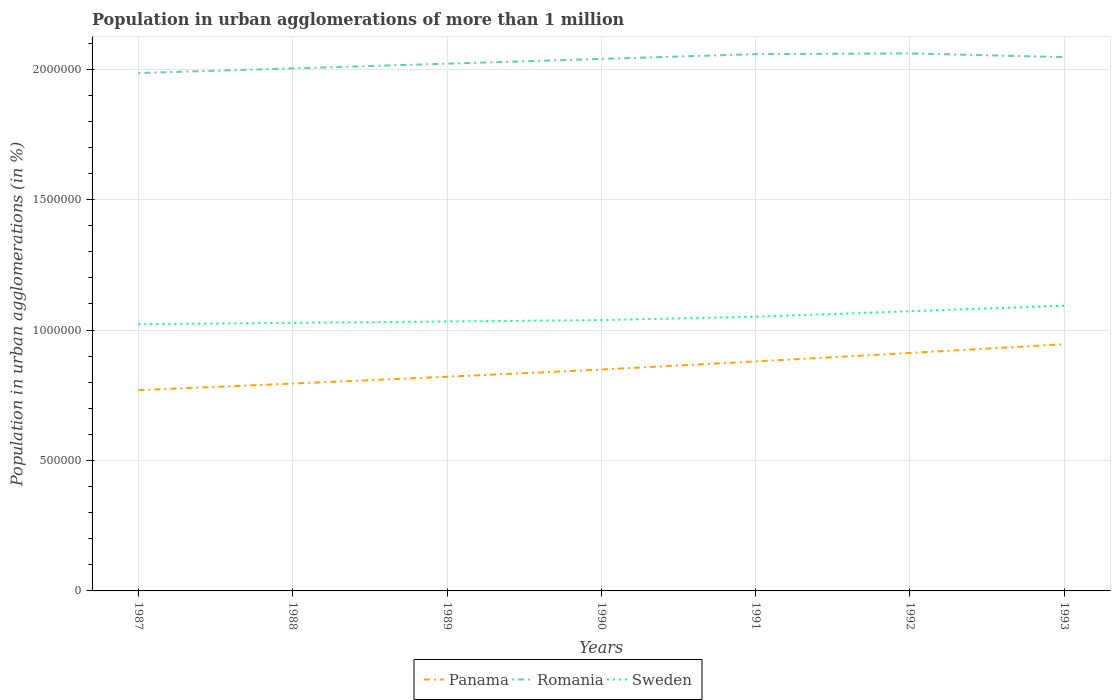Across all years, what is the maximum population in urban agglomerations in Sweden?
Provide a succinct answer. 1.02e+06. In which year was the population in urban agglomerations in Panama maximum?
Your answer should be compact. 1987. What is the total population in urban agglomerations in Romania in the graph?
Your response must be concise. -3.93e+04. What is the difference between the highest and the second highest population in urban agglomerations in Panama?
Provide a succinct answer. 1.76e+05. How many years are there in the graph?
Your answer should be compact. 7. What is the difference between two consecutive major ticks on the Y-axis?
Provide a succinct answer. 5.00e+05. Are the values on the major ticks of Y-axis written in scientific E-notation?
Provide a short and direct response. No. Does the graph contain grids?
Provide a succinct answer. Yes. How many legend labels are there?
Ensure brevity in your answer.  3. What is the title of the graph?
Keep it short and to the point. Population in urban agglomerations of more than 1 million. Does "Arab World" appear as one of the legend labels in the graph?
Your response must be concise. No. What is the label or title of the X-axis?
Offer a terse response. Years. What is the label or title of the Y-axis?
Your response must be concise. Population in urban agglomerations (in %). What is the Population in urban agglomerations (in %) of Panama in 1987?
Your response must be concise. 7.70e+05. What is the Population in urban agglomerations (in %) in Romania in 1987?
Make the answer very short. 1.99e+06. What is the Population in urban agglomerations (in %) of Sweden in 1987?
Offer a very short reply. 1.02e+06. What is the Population in urban agglomerations (in %) in Panama in 1988?
Your response must be concise. 7.95e+05. What is the Population in urban agglomerations (in %) of Romania in 1988?
Make the answer very short. 2.00e+06. What is the Population in urban agglomerations (in %) of Sweden in 1988?
Keep it short and to the point. 1.03e+06. What is the Population in urban agglomerations (in %) in Panama in 1989?
Ensure brevity in your answer.  8.21e+05. What is the Population in urban agglomerations (in %) in Romania in 1989?
Offer a very short reply. 2.02e+06. What is the Population in urban agglomerations (in %) of Sweden in 1989?
Your response must be concise. 1.03e+06. What is the Population in urban agglomerations (in %) in Panama in 1990?
Provide a short and direct response. 8.49e+05. What is the Population in urban agglomerations (in %) of Romania in 1990?
Provide a succinct answer. 2.04e+06. What is the Population in urban agglomerations (in %) in Sweden in 1990?
Make the answer very short. 1.04e+06. What is the Population in urban agglomerations (in %) in Panama in 1991?
Give a very brief answer. 8.80e+05. What is the Population in urban agglomerations (in %) of Romania in 1991?
Offer a very short reply. 2.06e+06. What is the Population in urban agglomerations (in %) of Sweden in 1991?
Your response must be concise. 1.05e+06. What is the Population in urban agglomerations (in %) in Panama in 1992?
Provide a succinct answer. 9.12e+05. What is the Population in urban agglomerations (in %) of Romania in 1992?
Your answer should be very brief. 2.06e+06. What is the Population in urban agglomerations (in %) of Sweden in 1992?
Give a very brief answer. 1.07e+06. What is the Population in urban agglomerations (in %) in Panama in 1993?
Give a very brief answer. 9.46e+05. What is the Population in urban agglomerations (in %) of Romania in 1993?
Give a very brief answer. 2.05e+06. What is the Population in urban agglomerations (in %) of Sweden in 1993?
Keep it short and to the point. 1.09e+06. Across all years, what is the maximum Population in urban agglomerations (in %) in Panama?
Your response must be concise. 9.46e+05. Across all years, what is the maximum Population in urban agglomerations (in %) in Romania?
Your response must be concise. 2.06e+06. Across all years, what is the maximum Population in urban agglomerations (in %) of Sweden?
Keep it short and to the point. 1.09e+06. Across all years, what is the minimum Population in urban agglomerations (in %) in Panama?
Offer a terse response. 7.70e+05. Across all years, what is the minimum Population in urban agglomerations (in %) of Romania?
Keep it short and to the point. 1.99e+06. Across all years, what is the minimum Population in urban agglomerations (in %) in Sweden?
Provide a succinct answer. 1.02e+06. What is the total Population in urban agglomerations (in %) in Panama in the graph?
Your answer should be very brief. 5.97e+06. What is the total Population in urban agglomerations (in %) in Romania in the graph?
Make the answer very short. 1.42e+07. What is the total Population in urban agglomerations (in %) in Sweden in the graph?
Give a very brief answer. 7.34e+06. What is the difference between the Population in urban agglomerations (in %) of Panama in 1987 and that in 1988?
Your answer should be very brief. -2.54e+04. What is the difference between the Population in urban agglomerations (in %) of Romania in 1987 and that in 1988?
Give a very brief answer. -1.79e+04. What is the difference between the Population in urban agglomerations (in %) of Sweden in 1987 and that in 1988?
Make the answer very short. -5207. What is the difference between the Population in urban agglomerations (in %) of Panama in 1987 and that in 1989?
Your answer should be very brief. -5.16e+04. What is the difference between the Population in urban agglomerations (in %) of Romania in 1987 and that in 1989?
Keep it short and to the point. -3.59e+04. What is the difference between the Population in urban agglomerations (in %) of Sweden in 1987 and that in 1989?
Offer a very short reply. -1.04e+04. What is the difference between the Population in urban agglomerations (in %) of Panama in 1987 and that in 1990?
Make the answer very short. -7.91e+04. What is the difference between the Population in urban agglomerations (in %) of Romania in 1987 and that in 1990?
Your answer should be compact. -5.41e+04. What is the difference between the Population in urban agglomerations (in %) in Sweden in 1987 and that in 1990?
Give a very brief answer. -1.57e+04. What is the difference between the Population in urban agglomerations (in %) of Panama in 1987 and that in 1991?
Keep it short and to the point. -1.10e+05. What is the difference between the Population in urban agglomerations (in %) of Romania in 1987 and that in 1991?
Your answer should be very brief. -7.25e+04. What is the difference between the Population in urban agglomerations (in %) in Sweden in 1987 and that in 1991?
Keep it short and to the point. -2.86e+04. What is the difference between the Population in urban agglomerations (in %) of Panama in 1987 and that in 1992?
Your answer should be compact. -1.43e+05. What is the difference between the Population in urban agglomerations (in %) in Romania in 1987 and that in 1992?
Make the answer very short. -7.53e+04. What is the difference between the Population in urban agglomerations (in %) in Sweden in 1987 and that in 1992?
Ensure brevity in your answer.  -4.96e+04. What is the difference between the Population in urban agglomerations (in %) of Panama in 1987 and that in 1993?
Offer a very short reply. -1.76e+05. What is the difference between the Population in urban agglomerations (in %) of Romania in 1987 and that in 1993?
Your answer should be very brief. -6.10e+04. What is the difference between the Population in urban agglomerations (in %) of Sweden in 1987 and that in 1993?
Provide a short and direct response. -7.10e+04. What is the difference between the Population in urban agglomerations (in %) of Panama in 1988 and that in 1989?
Your answer should be very brief. -2.62e+04. What is the difference between the Population in urban agglomerations (in %) in Romania in 1988 and that in 1989?
Give a very brief answer. -1.80e+04. What is the difference between the Population in urban agglomerations (in %) in Sweden in 1988 and that in 1989?
Give a very brief answer. -5220. What is the difference between the Population in urban agglomerations (in %) of Panama in 1988 and that in 1990?
Ensure brevity in your answer.  -5.37e+04. What is the difference between the Population in urban agglomerations (in %) in Romania in 1988 and that in 1990?
Provide a short and direct response. -3.62e+04. What is the difference between the Population in urban agglomerations (in %) of Sweden in 1988 and that in 1990?
Provide a succinct answer. -1.05e+04. What is the difference between the Population in urban agglomerations (in %) of Panama in 1988 and that in 1991?
Provide a succinct answer. -8.49e+04. What is the difference between the Population in urban agglomerations (in %) of Romania in 1988 and that in 1991?
Make the answer very short. -5.46e+04. What is the difference between the Population in urban agglomerations (in %) in Sweden in 1988 and that in 1991?
Make the answer very short. -2.34e+04. What is the difference between the Population in urban agglomerations (in %) in Panama in 1988 and that in 1992?
Your response must be concise. -1.17e+05. What is the difference between the Population in urban agglomerations (in %) in Romania in 1988 and that in 1992?
Offer a terse response. -5.74e+04. What is the difference between the Population in urban agglomerations (in %) in Sweden in 1988 and that in 1992?
Your response must be concise. -4.44e+04. What is the difference between the Population in urban agglomerations (in %) of Panama in 1988 and that in 1993?
Provide a short and direct response. -1.51e+05. What is the difference between the Population in urban agglomerations (in %) in Romania in 1988 and that in 1993?
Offer a terse response. -4.31e+04. What is the difference between the Population in urban agglomerations (in %) of Sweden in 1988 and that in 1993?
Make the answer very short. -6.58e+04. What is the difference between the Population in urban agglomerations (in %) of Panama in 1989 and that in 1990?
Make the answer very short. -2.75e+04. What is the difference between the Population in urban agglomerations (in %) of Romania in 1989 and that in 1990?
Ensure brevity in your answer.  -1.82e+04. What is the difference between the Population in urban agglomerations (in %) in Sweden in 1989 and that in 1990?
Ensure brevity in your answer.  -5253. What is the difference between the Population in urban agglomerations (in %) of Panama in 1989 and that in 1991?
Your answer should be very brief. -5.87e+04. What is the difference between the Population in urban agglomerations (in %) in Romania in 1989 and that in 1991?
Provide a succinct answer. -3.66e+04. What is the difference between the Population in urban agglomerations (in %) of Sweden in 1989 and that in 1991?
Your answer should be very brief. -1.82e+04. What is the difference between the Population in urban agglomerations (in %) of Panama in 1989 and that in 1992?
Ensure brevity in your answer.  -9.11e+04. What is the difference between the Population in urban agglomerations (in %) of Romania in 1989 and that in 1992?
Your response must be concise. -3.93e+04. What is the difference between the Population in urban agglomerations (in %) of Sweden in 1989 and that in 1992?
Your answer should be compact. -3.92e+04. What is the difference between the Population in urban agglomerations (in %) in Panama in 1989 and that in 1993?
Offer a terse response. -1.25e+05. What is the difference between the Population in urban agglomerations (in %) of Romania in 1989 and that in 1993?
Give a very brief answer. -2.51e+04. What is the difference between the Population in urban agglomerations (in %) of Sweden in 1989 and that in 1993?
Keep it short and to the point. -6.06e+04. What is the difference between the Population in urban agglomerations (in %) in Panama in 1990 and that in 1991?
Ensure brevity in your answer.  -3.12e+04. What is the difference between the Population in urban agglomerations (in %) in Romania in 1990 and that in 1991?
Your answer should be compact. -1.84e+04. What is the difference between the Population in urban agglomerations (in %) in Sweden in 1990 and that in 1991?
Ensure brevity in your answer.  -1.29e+04. What is the difference between the Population in urban agglomerations (in %) in Panama in 1990 and that in 1992?
Provide a succinct answer. -6.36e+04. What is the difference between the Population in urban agglomerations (in %) in Romania in 1990 and that in 1992?
Offer a terse response. -2.11e+04. What is the difference between the Population in urban agglomerations (in %) in Sweden in 1990 and that in 1992?
Your response must be concise. -3.39e+04. What is the difference between the Population in urban agglomerations (in %) in Panama in 1990 and that in 1993?
Provide a succinct answer. -9.71e+04. What is the difference between the Population in urban agglomerations (in %) in Romania in 1990 and that in 1993?
Your response must be concise. -6881. What is the difference between the Population in urban agglomerations (in %) of Sweden in 1990 and that in 1993?
Give a very brief answer. -5.53e+04. What is the difference between the Population in urban agglomerations (in %) in Panama in 1991 and that in 1992?
Offer a terse response. -3.24e+04. What is the difference between the Population in urban agglomerations (in %) of Romania in 1991 and that in 1992?
Provide a succinct answer. -2740. What is the difference between the Population in urban agglomerations (in %) of Sweden in 1991 and that in 1992?
Keep it short and to the point. -2.10e+04. What is the difference between the Population in urban agglomerations (in %) in Panama in 1991 and that in 1993?
Your response must be concise. -6.59e+04. What is the difference between the Population in urban agglomerations (in %) of Romania in 1991 and that in 1993?
Provide a short and direct response. 1.15e+04. What is the difference between the Population in urban agglomerations (in %) of Sweden in 1991 and that in 1993?
Make the answer very short. -4.24e+04. What is the difference between the Population in urban agglomerations (in %) in Panama in 1992 and that in 1993?
Your response must be concise. -3.35e+04. What is the difference between the Population in urban agglomerations (in %) in Romania in 1992 and that in 1993?
Your answer should be very brief. 1.42e+04. What is the difference between the Population in urban agglomerations (in %) in Sweden in 1992 and that in 1993?
Ensure brevity in your answer.  -2.14e+04. What is the difference between the Population in urban agglomerations (in %) of Panama in 1987 and the Population in urban agglomerations (in %) of Romania in 1988?
Provide a succinct answer. -1.23e+06. What is the difference between the Population in urban agglomerations (in %) in Panama in 1987 and the Population in urban agglomerations (in %) in Sweden in 1988?
Offer a terse response. -2.58e+05. What is the difference between the Population in urban agglomerations (in %) in Romania in 1987 and the Population in urban agglomerations (in %) in Sweden in 1988?
Your answer should be very brief. 9.58e+05. What is the difference between the Population in urban agglomerations (in %) in Panama in 1987 and the Population in urban agglomerations (in %) in Romania in 1989?
Your answer should be compact. -1.25e+06. What is the difference between the Population in urban agglomerations (in %) of Panama in 1987 and the Population in urban agglomerations (in %) of Sweden in 1989?
Provide a short and direct response. -2.63e+05. What is the difference between the Population in urban agglomerations (in %) of Romania in 1987 and the Population in urban agglomerations (in %) of Sweden in 1989?
Your answer should be very brief. 9.52e+05. What is the difference between the Population in urban agglomerations (in %) in Panama in 1987 and the Population in urban agglomerations (in %) in Romania in 1990?
Keep it short and to the point. -1.27e+06. What is the difference between the Population in urban agglomerations (in %) in Panama in 1987 and the Population in urban agglomerations (in %) in Sweden in 1990?
Give a very brief answer. -2.69e+05. What is the difference between the Population in urban agglomerations (in %) in Romania in 1987 and the Population in urban agglomerations (in %) in Sweden in 1990?
Offer a terse response. 9.47e+05. What is the difference between the Population in urban agglomerations (in %) in Panama in 1987 and the Population in urban agglomerations (in %) in Romania in 1991?
Offer a very short reply. -1.29e+06. What is the difference between the Population in urban agglomerations (in %) of Panama in 1987 and the Population in urban agglomerations (in %) of Sweden in 1991?
Keep it short and to the point. -2.82e+05. What is the difference between the Population in urban agglomerations (in %) of Romania in 1987 and the Population in urban agglomerations (in %) of Sweden in 1991?
Provide a succinct answer. 9.34e+05. What is the difference between the Population in urban agglomerations (in %) of Panama in 1987 and the Population in urban agglomerations (in %) of Romania in 1992?
Offer a very short reply. -1.29e+06. What is the difference between the Population in urban agglomerations (in %) in Panama in 1987 and the Population in urban agglomerations (in %) in Sweden in 1992?
Provide a succinct answer. -3.03e+05. What is the difference between the Population in urban agglomerations (in %) in Romania in 1987 and the Population in urban agglomerations (in %) in Sweden in 1992?
Provide a succinct answer. 9.13e+05. What is the difference between the Population in urban agglomerations (in %) in Panama in 1987 and the Population in urban agglomerations (in %) in Romania in 1993?
Keep it short and to the point. -1.28e+06. What is the difference between the Population in urban agglomerations (in %) in Panama in 1987 and the Population in urban agglomerations (in %) in Sweden in 1993?
Make the answer very short. -3.24e+05. What is the difference between the Population in urban agglomerations (in %) of Romania in 1987 and the Population in urban agglomerations (in %) of Sweden in 1993?
Your response must be concise. 8.92e+05. What is the difference between the Population in urban agglomerations (in %) of Panama in 1988 and the Population in urban agglomerations (in %) of Romania in 1989?
Provide a short and direct response. -1.23e+06. What is the difference between the Population in urban agglomerations (in %) in Panama in 1988 and the Population in urban agglomerations (in %) in Sweden in 1989?
Offer a very short reply. -2.38e+05. What is the difference between the Population in urban agglomerations (in %) in Romania in 1988 and the Population in urban agglomerations (in %) in Sweden in 1989?
Your response must be concise. 9.70e+05. What is the difference between the Population in urban agglomerations (in %) in Panama in 1988 and the Population in urban agglomerations (in %) in Romania in 1990?
Your answer should be compact. -1.24e+06. What is the difference between the Population in urban agglomerations (in %) of Panama in 1988 and the Population in urban agglomerations (in %) of Sweden in 1990?
Offer a terse response. -2.43e+05. What is the difference between the Population in urban agglomerations (in %) in Romania in 1988 and the Population in urban agglomerations (in %) in Sweden in 1990?
Your answer should be very brief. 9.65e+05. What is the difference between the Population in urban agglomerations (in %) of Panama in 1988 and the Population in urban agglomerations (in %) of Romania in 1991?
Ensure brevity in your answer.  -1.26e+06. What is the difference between the Population in urban agglomerations (in %) in Panama in 1988 and the Population in urban agglomerations (in %) in Sweden in 1991?
Your response must be concise. -2.56e+05. What is the difference between the Population in urban agglomerations (in %) of Romania in 1988 and the Population in urban agglomerations (in %) of Sweden in 1991?
Offer a very short reply. 9.52e+05. What is the difference between the Population in urban agglomerations (in %) of Panama in 1988 and the Population in urban agglomerations (in %) of Romania in 1992?
Keep it short and to the point. -1.27e+06. What is the difference between the Population in urban agglomerations (in %) in Panama in 1988 and the Population in urban agglomerations (in %) in Sweden in 1992?
Your answer should be compact. -2.77e+05. What is the difference between the Population in urban agglomerations (in %) in Romania in 1988 and the Population in urban agglomerations (in %) in Sweden in 1992?
Provide a short and direct response. 9.31e+05. What is the difference between the Population in urban agglomerations (in %) in Panama in 1988 and the Population in urban agglomerations (in %) in Romania in 1993?
Offer a very short reply. -1.25e+06. What is the difference between the Population in urban agglomerations (in %) in Panama in 1988 and the Population in urban agglomerations (in %) in Sweden in 1993?
Provide a succinct answer. -2.99e+05. What is the difference between the Population in urban agglomerations (in %) in Romania in 1988 and the Population in urban agglomerations (in %) in Sweden in 1993?
Make the answer very short. 9.10e+05. What is the difference between the Population in urban agglomerations (in %) of Panama in 1989 and the Population in urban agglomerations (in %) of Romania in 1990?
Make the answer very short. -1.22e+06. What is the difference between the Population in urban agglomerations (in %) of Panama in 1989 and the Population in urban agglomerations (in %) of Sweden in 1990?
Your answer should be very brief. -2.17e+05. What is the difference between the Population in urban agglomerations (in %) in Romania in 1989 and the Population in urban agglomerations (in %) in Sweden in 1990?
Offer a terse response. 9.83e+05. What is the difference between the Population in urban agglomerations (in %) of Panama in 1989 and the Population in urban agglomerations (in %) of Romania in 1991?
Your answer should be compact. -1.24e+06. What is the difference between the Population in urban agglomerations (in %) of Panama in 1989 and the Population in urban agglomerations (in %) of Sweden in 1991?
Provide a short and direct response. -2.30e+05. What is the difference between the Population in urban agglomerations (in %) of Romania in 1989 and the Population in urban agglomerations (in %) of Sweden in 1991?
Ensure brevity in your answer.  9.70e+05. What is the difference between the Population in urban agglomerations (in %) of Panama in 1989 and the Population in urban agglomerations (in %) of Romania in 1992?
Provide a short and direct response. -1.24e+06. What is the difference between the Population in urban agglomerations (in %) of Panama in 1989 and the Population in urban agglomerations (in %) of Sweden in 1992?
Provide a succinct answer. -2.51e+05. What is the difference between the Population in urban agglomerations (in %) of Romania in 1989 and the Population in urban agglomerations (in %) of Sweden in 1992?
Your response must be concise. 9.49e+05. What is the difference between the Population in urban agglomerations (in %) of Panama in 1989 and the Population in urban agglomerations (in %) of Romania in 1993?
Your response must be concise. -1.23e+06. What is the difference between the Population in urban agglomerations (in %) in Panama in 1989 and the Population in urban agglomerations (in %) in Sweden in 1993?
Keep it short and to the point. -2.72e+05. What is the difference between the Population in urban agglomerations (in %) of Romania in 1989 and the Population in urban agglomerations (in %) of Sweden in 1993?
Make the answer very short. 9.28e+05. What is the difference between the Population in urban agglomerations (in %) in Panama in 1990 and the Population in urban agglomerations (in %) in Romania in 1991?
Provide a succinct answer. -1.21e+06. What is the difference between the Population in urban agglomerations (in %) of Panama in 1990 and the Population in urban agglomerations (in %) of Sweden in 1991?
Your answer should be compact. -2.03e+05. What is the difference between the Population in urban agglomerations (in %) in Romania in 1990 and the Population in urban agglomerations (in %) in Sweden in 1991?
Your answer should be compact. 9.88e+05. What is the difference between the Population in urban agglomerations (in %) of Panama in 1990 and the Population in urban agglomerations (in %) of Romania in 1992?
Provide a short and direct response. -1.21e+06. What is the difference between the Population in urban agglomerations (in %) in Panama in 1990 and the Population in urban agglomerations (in %) in Sweden in 1992?
Offer a terse response. -2.24e+05. What is the difference between the Population in urban agglomerations (in %) of Romania in 1990 and the Population in urban agglomerations (in %) of Sweden in 1992?
Keep it short and to the point. 9.67e+05. What is the difference between the Population in urban agglomerations (in %) of Panama in 1990 and the Population in urban agglomerations (in %) of Romania in 1993?
Keep it short and to the point. -1.20e+06. What is the difference between the Population in urban agglomerations (in %) of Panama in 1990 and the Population in urban agglomerations (in %) of Sweden in 1993?
Provide a succinct answer. -2.45e+05. What is the difference between the Population in urban agglomerations (in %) of Romania in 1990 and the Population in urban agglomerations (in %) of Sweden in 1993?
Offer a terse response. 9.46e+05. What is the difference between the Population in urban agglomerations (in %) in Panama in 1991 and the Population in urban agglomerations (in %) in Romania in 1992?
Your answer should be very brief. -1.18e+06. What is the difference between the Population in urban agglomerations (in %) in Panama in 1991 and the Population in urban agglomerations (in %) in Sweden in 1992?
Provide a short and direct response. -1.92e+05. What is the difference between the Population in urban agglomerations (in %) of Romania in 1991 and the Population in urban agglomerations (in %) of Sweden in 1992?
Keep it short and to the point. 9.86e+05. What is the difference between the Population in urban agglomerations (in %) in Panama in 1991 and the Population in urban agglomerations (in %) in Romania in 1993?
Provide a short and direct response. -1.17e+06. What is the difference between the Population in urban agglomerations (in %) in Panama in 1991 and the Population in urban agglomerations (in %) in Sweden in 1993?
Your response must be concise. -2.14e+05. What is the difference between the Population in urban agglomerations (in %) of Romania in 1991 and the Population in urban agglomerations (in %) of Sweden in 1993?
Keep it short and to the point. 9.64e+05. What is the difference between the Population in urban agglomerations (in %) of Panama in 1992 and the Population in urban agglomerations (in %) of Romania in 1993?
Give a very brief answer. -1.13e+06. What is the difference between the Population in urban agglomerations (in %) in Panama in 1992 and the Population in urban agglomerations (in %) in Sweden in 1993?
Provide a succinct answer. -1.81e+05. What is the difference between the Population in urban agglomerations (in %) of Romania in 1992 and the Population in urban agglomerations (in %) of Sweden in 1993?
Give a very brief answer. 9.67e+05. What is the average Population in urban agglomerations (in %) of Panama per year?
Give a very brief answer. 8.53e+05. What is the average Population in urban agglomerations (in %) of Romania per year?
Offer a very short reply. 2.03e+06. What is the average Population in urban agglomerations (in %) of Sweden per year?
Keep it short and to the point. 1.05e+06. In the year 1987, what is the difference between the Population in urban agglomerations (in %) in Panama and Population in urban agglomerations (in %) in Romania?
Ensure brevity in your answer.  -1.22e+06. In the year 1987, what is the difference between the Population in urban agglomerations (in %) of Panama and Population in urban agglomerations (in %) of Sweden?
Your answer should be very brief. -2.53e+05. In the year 1987, what is the difference between the Population in urban agglomerations (in %) in Romania and Population in urban agglomerations (in %) in Sweden?
Your answer should be very brief. 9.63e+05. In the year 1988, what is the difference between the Population in urban agglomerations (in %) of Panama and Population in urban agglomerations (in %) of Romania?
Give a very brief answer. -1.21e+06. In the year 1988, what is the difference between the Population in urban agglomerations (in %) in Panama and Population in urban agglomerations (in %) in Sweden?
Your answer should be very brief. -2.33e+05. In the year 1988, what is the difference between the Population in urban agglomerations (in %) in Romania and Population in urban agglomerations (in %) in Sweden?
Your answer should be compact. 9.76e+05. In the year 1989, what is the difference between the Population in urban agglomerations (in %) in Panama and Population in urban agglomerations (in %) in Romania?
Keep it short and to the point. -1.20e+06. In the year 1989, what is the difference between the Population in urban agglomerations (in %) in Panama and Population in urban agglomerations (in %) in Sweden?
Make the answer very short. -2.12e+05. In the year 1989, what is the difference between the Population in urban agglomerations (in %) of Romania and Population in urban agglomerations (in %) of Sweden?
Your answer should be compact. 9.88e+05. In the year 1990, what is the difference between the Population in urban agglomerations (in %) of Panama and Population in urban agglomerations (in %) of Romania?
Provide a succinct answer. -1.19e+06. In the year 1990, what is the difference between the Population in urban agglomerations (in %) in Panama and Population in urban agglomerations (in %) in Sweden?
Make the answer very short. -1.90e+05. In the year 1990, what is the difference between the Population in urban agglomerations (in %) of Romania and Population in urban agglomerations (in %) of Sweden?
Make the answer very short. 1.00e+06. In the year 1991, what is the difference between the Population in urban agglomerations (in %) of Panama and Population in urban agglomerations (in %) of Romania?
Give a very brief answer. -1.18e+06. In the year 1991, what is the difference between the Population in urban agglomerations (in %) in Panama and Population in urban agglomerations (in %) in Sweden?
Your answer should be very brief. -1.71e+05. In the year 1991, what is the difference between the Population in urban agglomerations (in %) of Romania and Population in urban agglomerations (in %) of Sweden?
Ensure brevity in your answer.  1.01e+06. In the year 1992, what is the difference between the Population in urban agglomerations (in %) in Panama and Population in urban agglomerations (in %) in Romania?
Make the answer very short. -1.15e+06. In the year 1992, what is the difference between the Population in urban agglomerations (in %) in Panama and Population in urban agglomerations (in %) in Sweden?
Offer a very short reply. -1.60e+05. In the year 1992, what is the difference between the Population in urban agglomerations (in %) in Romania and Population in urban agglomerations (in %) in Sweden?
Offer a very short reply. 9.88e+05. In the year 1993, what is the difference between the Population in urban agglomerations (in %) of Panama and Population in urban agglomerations (in %) of Romania?
Your response must be concise. -1.10e+06. In the year 1993, what is the difference between the Population in urban agglomerations (in %) of Panama and Population in urban agglomerations (in %) of Sweden?
Your answer should be very brief. -1.48e+05. In the year 1993, what is the difference between the Population in urban agglomerations (in %) of Romania and Population in urban agglomerations (in %) of Sweden?
Offer a very short reply. 9.53e+05. What is the ratio of the Population in urban agglomerations (in %) of Romania in 1987 to that in 1988?
Offer a very short reply. 0.99. What is the ratio of the Population in urban agglomerations (in %) of Sweden in 1987 to that in 1988?
Make the answer very short. 0.99. What is the ratio of the Population in urban agglomerations (in %) in Panama in 1987 to that in 1989?
Provide a short and direct response. 0.94. What is the ratio of the Population in urban agglomerations (in %) of Romania in 1987 to that in 1989?
Offer a terse response. 0.98. What is the ratio of the Population in urban agglomerations (in %) of Panama in 1987 to that in 1990?
Your response must be concise. 0.91. What is the ratio of the Population in urban agglomerations (in %) in Romania in 1987 to that in 1990?
Provide a succinct answer. 0.97. What is the ratio of the Population in urban agglomerations (in %) in Sweden in 1987 to that in 1990?
Offer a terse response. 0.98. What is the ratio of the Population in urban agglomerations (in %) of Panama in 1987 to that in 1991?
Keep it short and to the point. 0.87. What is the ratio of the Population in urban agglomerations (in %) in Romania in 1987 to that in 1991?
Make the answer very short. 0.96. What is the ratio of the Population in urban agglomerations (in %) in Sweden in 1987 to that in 1991?
Ensure brevity in your answer.  0.97. What is the ratio of the Population in urban agglomerations (in %) in Panama in 1987 to that in 1992?
Keep it short and to the point. 0.84. What is the ratio of the Population in urban agglomerations (in %) of Romania in 1987 to that in 1992?
Provide a short and direct response. 0.96. What is the ratio of the Population in urban agglomerations (in %) in Sweden in 1987 to that in 1992?
Offer a terse response. 0.95. What is the ratio of the Population in urban agglomerations (in %) in Panama in 1987 to that in 1993?
Your answer should be very brief. 0.81. What is the ratio of the Population in urban agglomerations (in %) in Romania in 1987 to that in 1993?
Make the answer very short. 0.97. What is the ratio of the Population in urban agglomerations (in %) in Sweden in 1987 to that in 1993?
Make the answer very short. 0.94. What is the ratio of the Population in urban agglomerations (in %) in Panama in 1988 to that in 1989?
Your response must be concise. 0.97. What is the ratio of the Population in urban agglomerations (in %) of Romania in 1988 to that in 1989?
Your answer should be very brief. 0.99. What is the ratio of the Population in urban agglomerations (in %) in Panama in 1988 to that in 1990?
Keep it short and to the point. 0.94. What is the ratio of the Population in urban agglomerations (in %) in Romania in 1988 to that in 1990?
Offer a terse response. 0.98. What is the ratio of the Population in urban agglomerations (in %) of Panama in 1988 to that in 1991?
Offer a very short reply. 0.9. What is the ratio of the Population in urban agglomerations (in %) in Romania in 1988 to that in 1991?
Your response must be concise. 0.97. What is the ratio of the Population in urban agglomerations (in %) of Sweden in 1988 to that in 1991?
Ensure brevity in your answer.  0.98. What is the ratio of the Population in urban agglomerations (in %) in Panama in 1988 to that in 1992?
Your answer should be compact. 0.87. What is the ratio of the Population in urban agglomerations (in %) of Romania in 1988 to that in 1992?
Make the answer very short. 0.97. What is the ratio of the Population in urban agglomerations (in %) in Sweden in 1988 to that in 1992?
Make the answer very short. 0.96. What is the ratio of the Population in urban agglomerations (in %) of Panama in 1988 to that in 1993?
Give a very brief answer. 0.84. What is the ratio of the Population in urban agglomerations (in %) in Romania in 1988 to that in 1993?
Give a very brief answer. 0.98. What is the ratio of the Population in urban agglomerations (in %) in Sweden in 1988 to that in 1993?
Keep it short and to the point. 0.94. What is the ratio of the Population in urban agglomerations (in %) of Panama in 1989 to that in 1990?
Offer a very short reply. 0.97. What is the ratio of the Population in urban agglomerations (in %) in Romania in 1989 to that in 1991?
Keep it short and to the point. 0.98. What is the ratio of the Population in urban agglomerations (in %) of Sweden in 1989 to that in 1991?
Offer a very short reply. 0.98. What is the ratio of the Population in urban agglomerations (in %) in Panama in 1989 to that in 1992?
Offer a very short reply. 0.9. What is the ratio of the Population in urban agglomerations (in %) of Romania in 1989 to that in 1992?
Provide a succinct answer. 0.98. What is the ratio of the Population in urban agglomerations (in %) of Sweden in 1989 to that in 1992?
Your answer should be compact. 0.96. What is the ratio of the Population in urban agglomerations (in %) of Panama in 1989 to that in 1993?
Offer a very short reply. 0.87. What is the ratio of the Population in urban agglomerations (in %) of Sweden in 1989 to that in 1993?
Ensure brevity in your answer.  0.94. What is the ratio of the Population in urban agglomerations (in %) in Panama in 1990 to that in 1991?
Keep it short and to the point. 0.96. What is the ratio of the Population in urban agglomerations (in %) in Panama in 1990 to that in 1992?
Provide a succinct answer. 0.93. What is the ratio of the Population in urban agglomerations (in %) of Romania in 1990 to that in 1992?
Provide a succinct answer. 0.99. What is the ratio of the Population in urban agglomerations (in %) in Sweden in 1990 to that in 1992?
Give a very brief answer. 0.97. What is the ratio of the Population in urban agglomerations (in %) of Panama in 1990 to that in 1993?
Your answer should be very brief. 0.9. What is the ratio of the Population in urban agglomerations (in %) in Romania in 1990 to that in 1993?
Keep it short and to the point. 1. What is the ratio of the Population in urban agglomerations (in %) of Sweden in 1990 to that in 1993?
Your answer should be compact. 0.95. What is the ratio of the Population in urban agglomerations (in %) in Panama in 1991 to that in 1992?
Your answer should be very brief. 0.96. What is the ratio of the Population in urban agglomerations (in %) of Romania in 1991 to that in 1992?
Provide a succinct answer. 1. What is the ratio of the Population in urban agglomerations (in %) in Sweden in 1991 to that in 1992?
Your answer should be very brief. 0.98. What is the ratio of the Population in urban agglomerations (in %) in Panama in 1991 to that in 1993?
Offer a terse response. 0.93. What is the ratio of the Population in urban agglomerations (in %) in Romania in 1991 to that in 1993?
Your response must be concise. 1.01. What is the ratio of the Population in urban agglomerations (in %) in Sweden in 1991 to that in 1993?
Your answer should be very brief. 0.96. What is the ratio of the Population in urban agglomerations (in %) of Panama in 1992 to that in 1993?
Keep it short and to the point. 0.96. What is the ratio of the Population in urban agglomerations (in %) in Sweden in 1992 to that in 1993?
Make the answer very short. 0.98. What is the difference between the highest and the second highest Population in urban agglomerations (in %) in Panama?
Your answer should be compact. 3.35e+04. What is the difference between the highest and the second highest Population in urban agglomerations (in %) of Romania?
Your response must be concise. 2740. What is the difference between the highest and the second highest Population in urban agglomerations (in %) in Sweden?
Your response must be concise. 2.14e+04. What is the difference between the highest and the lowest Population in urban agglomerations (in %) in Panama?
Provide a short and direct response. 1.76e+05. What is the difference between the highest and the lowest Population in urban agglomerations (in %) of Romania?
Give a very brief answer. 7.53e+04. What is the difference between the highest and the lowest Population in urban agglomerations (in %) of Sweden?
Your answer should be compact. 7.10e+04. 